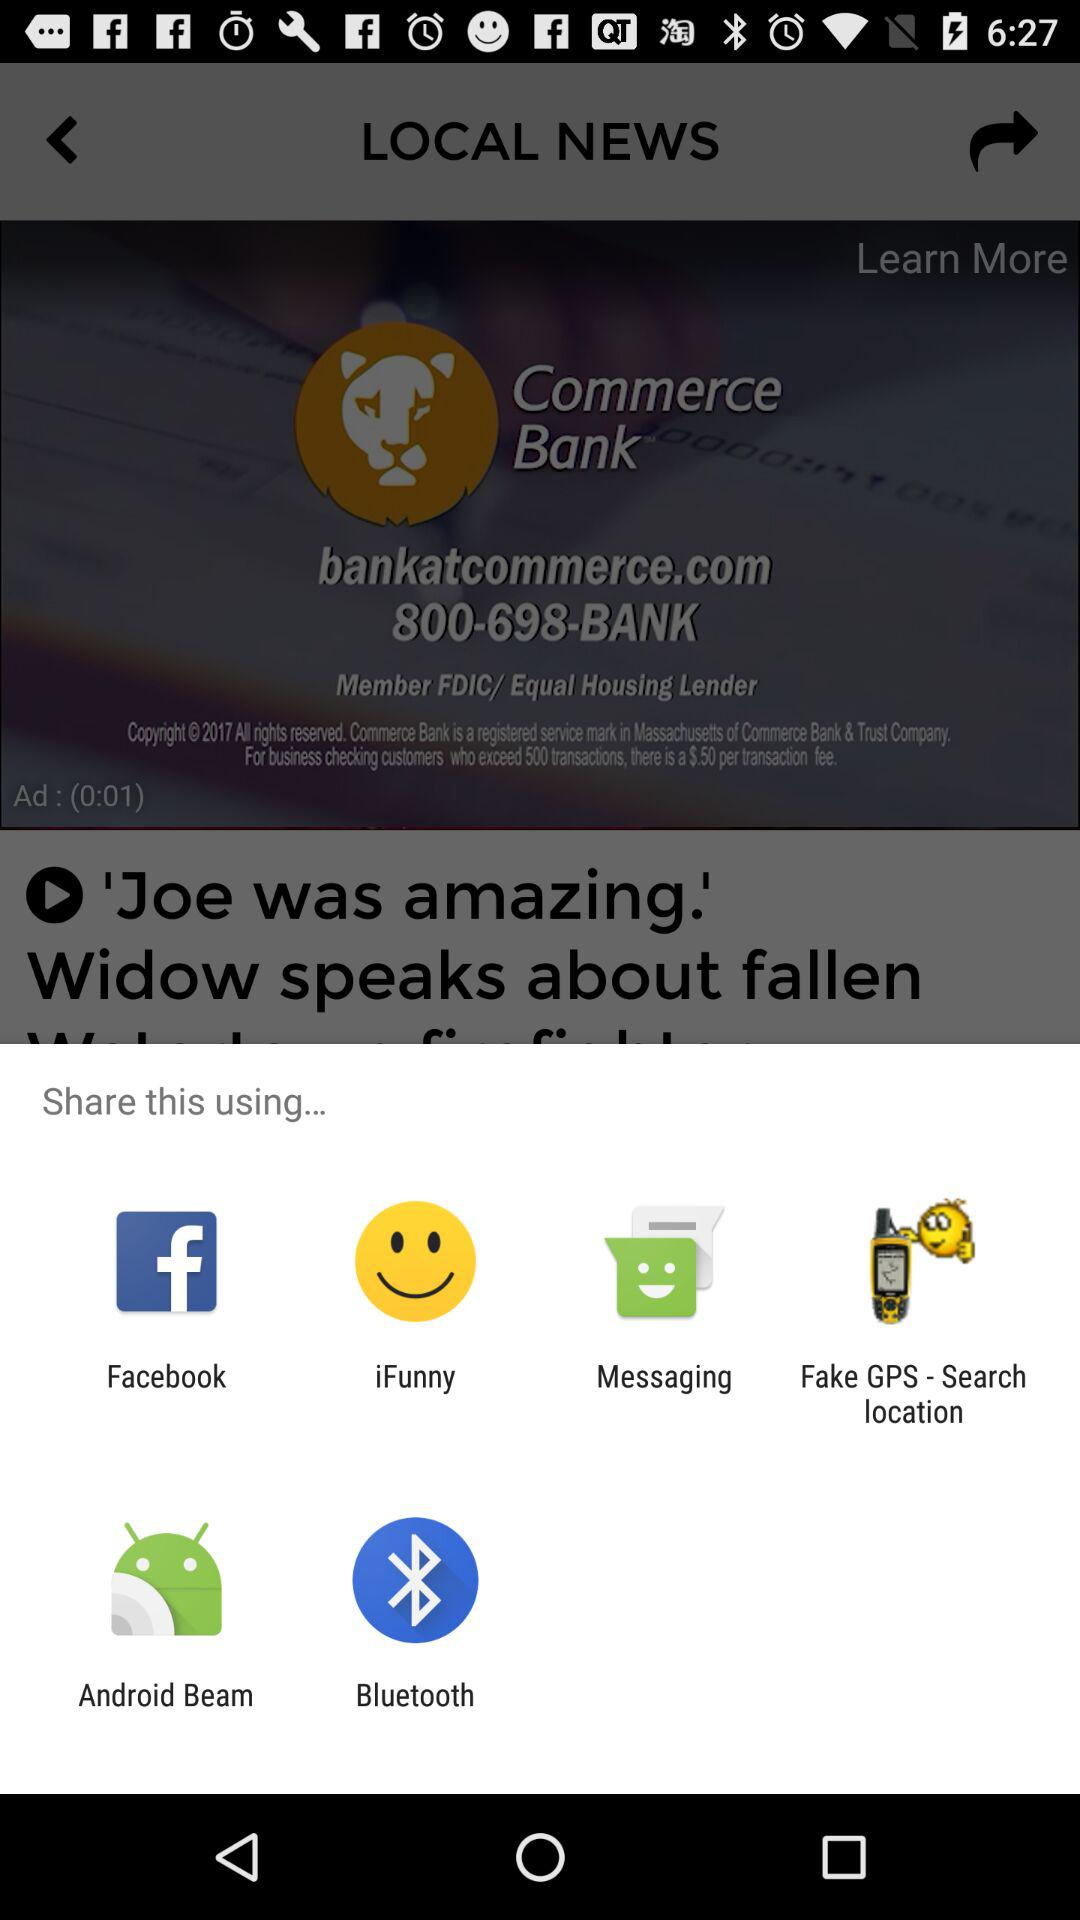Through what applications can you share? We can share through "Facebook", "iFunny", "Messaging", "Fake GPS-Search location", "Android Beam", and "Bluetooth". 